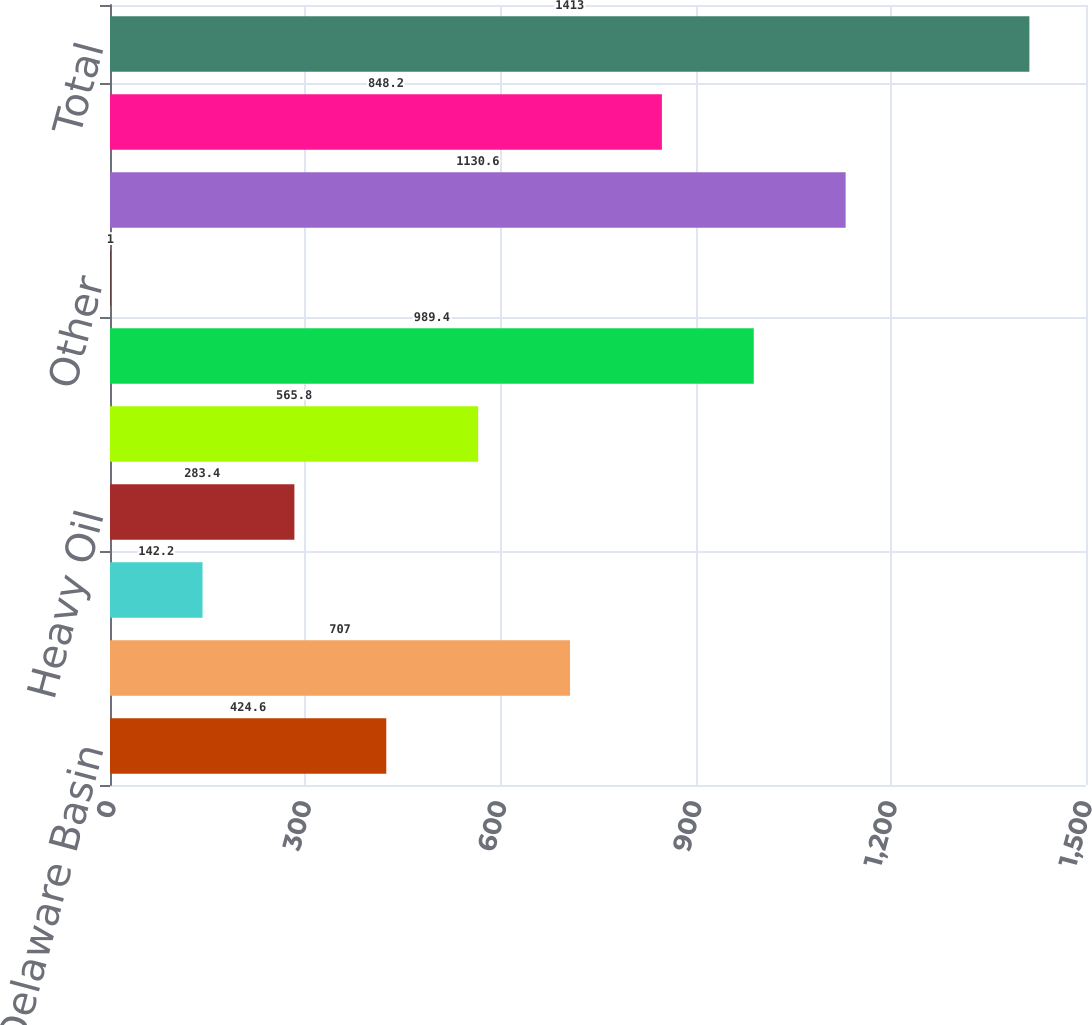Convert chart to OTSL. <chart><loc_0><loc_0><loc_500><loc_500><bar_chart><fcel>Delaware Basin<fcel>STACK<fcel>Rockies Oil<fcel>Heavy Oil<fcel>Eagle Ford<fcel>Barnett Shale<fcel>Other<fcel>Retained assets<fcel>US divested assets<fcel>Total<nl><fcel>424.6<fcel>707<fcel>142.2<fcel>283.4<fcel>565.8<fcel>989.4<fcel>1<fcel>1130.6<fcel>848.2<fcel>1413<nl></chart> 